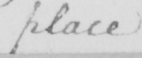What is written in this line of handwriting? place 